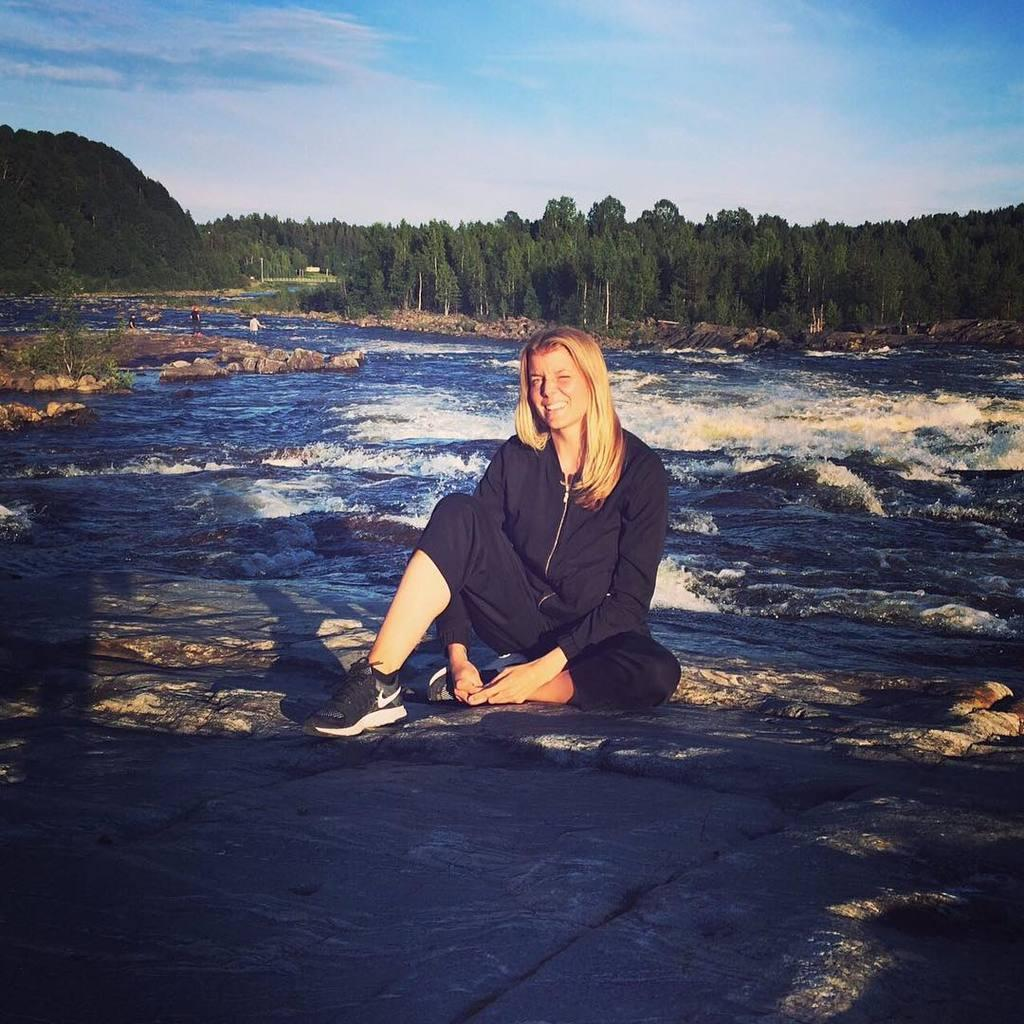What type of natural elements can be seen in the image? There are trees and water visible in the image. What other objects can be seen in the image? There are rocks and poles visible in the image. What is visible in the sky in the image? The sky is visible in the image. Are there any people present in the image? Yes, there are people in the image. What type of powder is being used by the aunt in the image? There is no aunt or powder present in the image. 